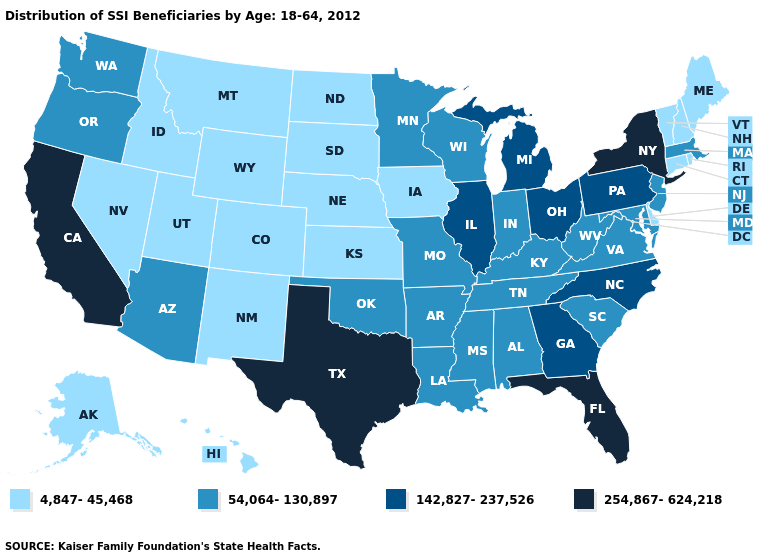Among the states that border Wyoming , which have the highest value?
Answer briefly. Colorado, Idaho, Montana, Nebraska, South Dakota, Utah. Name the states that have a value in the range 142,827-237,526?
Answer briefly. Georgia, Illinois, Michigan, North Carolina, Ohio, Pennsylvania. Among the states that border New Jersey , which have the highest value?
Keep it brief. New York. What is the value of New York?
Short answer required. 254,867-624,218. Does the map have missing data?
Give a very brief answer. No. What is the value of Texas?
Concise answer only. 254,867-624,218. Name the states that have a value in the range 142,827-237,526?
Keep it brief. Georgia, Illinois, Michigan, North Carolina, Ohio, Pennsylvania. Among the states that border New Hampshire , does Massachusetts have the lowest value?
Short answer required. No. Does Virginia have the highest value in the USA?
Quick response, please. No. What is the value of Oklahoma?
Answer briefly. 54,064-130,897. What is the value of Iowa?
Give a very brief answer. 4,847-45,468. Name the states that have a value in the range 254,867-624,218?
Answer briefly. California, Florida, New York, Texas. What is the lowest value in the Northeast?
Concise answer only. 4,847-45,468. What is the value of Illinois?
Answer briefly. 142,827-237,526. Which states have the lowest value in the USA?
Give a very brief answer. Alaska, Colorado, Connecticut, Delaware, Hawaii, Idaho, Iowa, Kansas, Maine, Montana, Nebraska, Nevada, New Hampshire, New Mexico, North Dakota, Rhode Island, South Dakota, Utah, Vermont, Wyoming. 